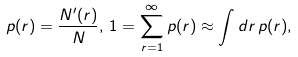<formula> <loc_0><loc_0><loc_500><loc_500>p ( r ) = \frac { N ^ { \prime } ( r ) } { N } , \, 1 = \sum _ { r = 1 } ^ { \infty } p ( r ) \approx \int d r \, p ( r ) ,</formula> 